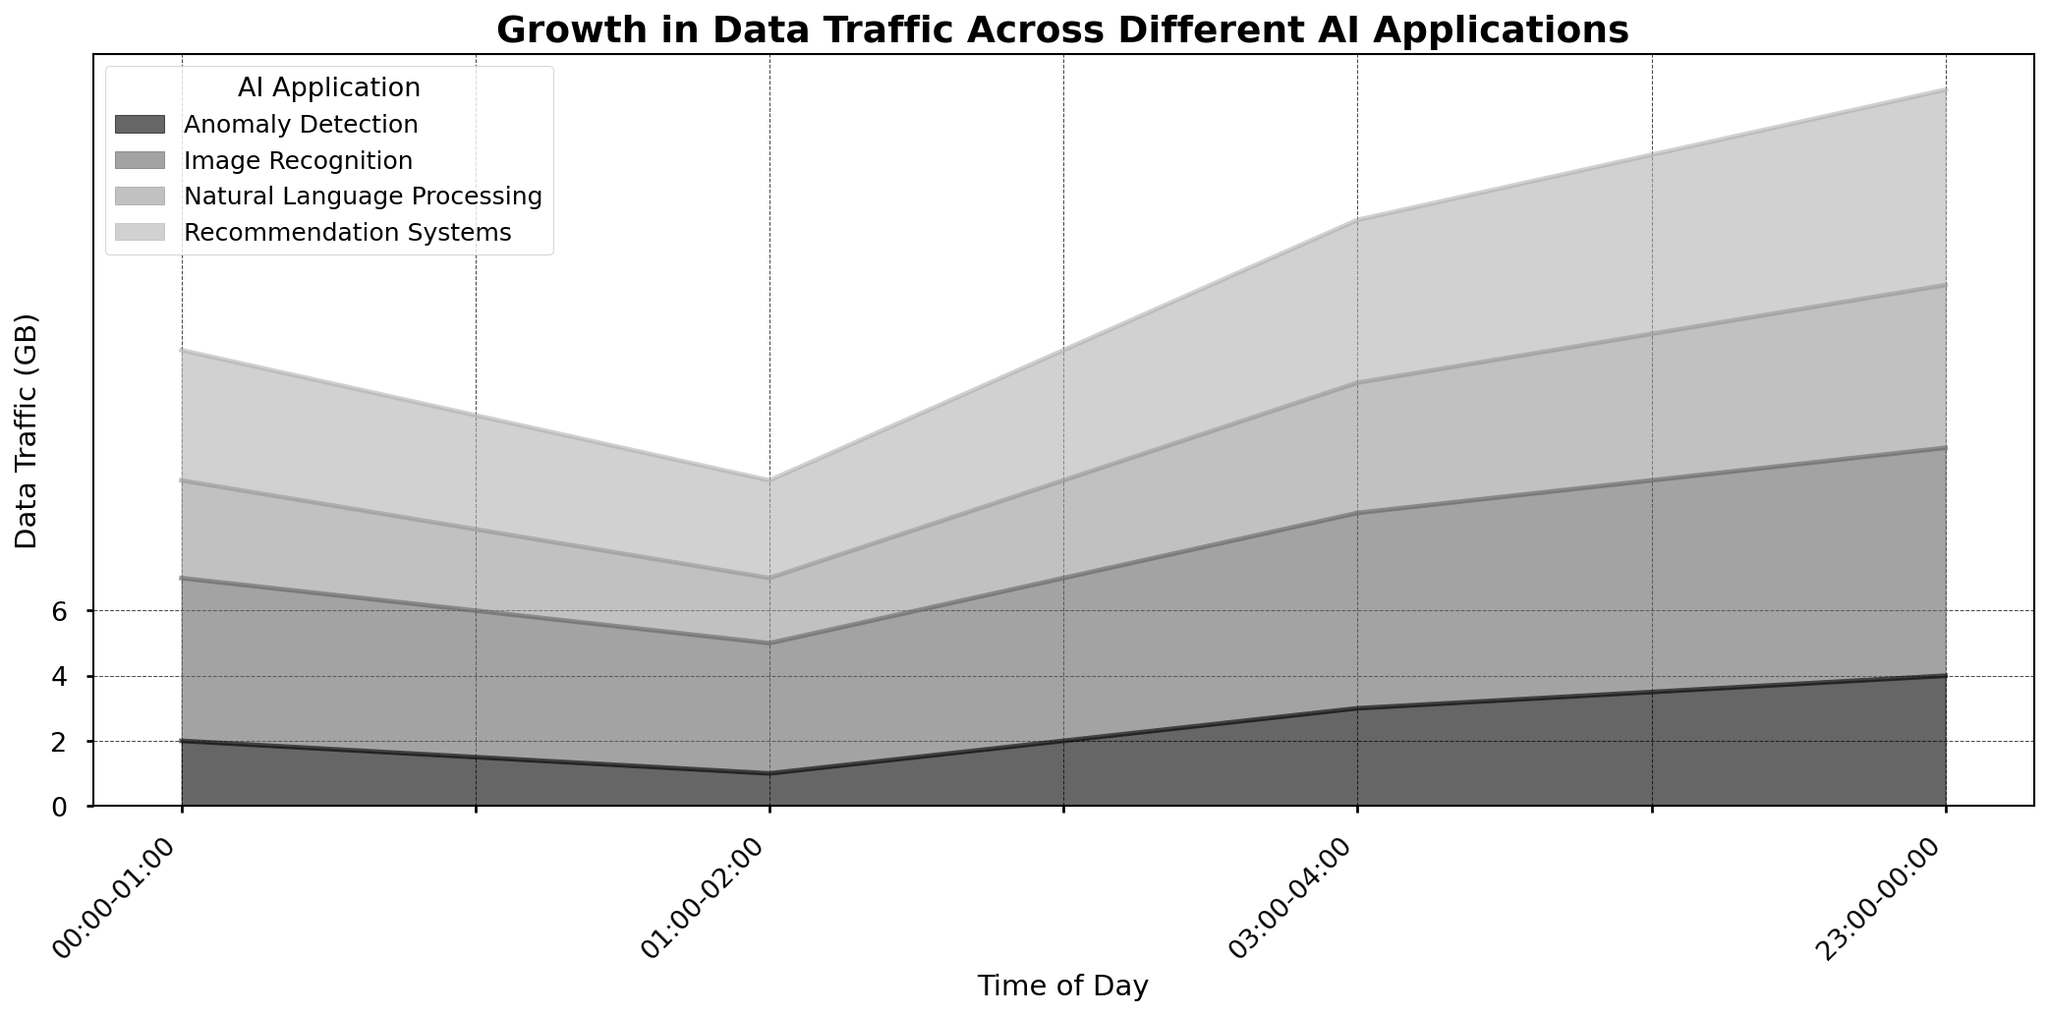What time of day has the highest total data traffic? To determine the time of day with the highest total data traffic, we need to sum the data traffic values for each time period across all AI applications. By looking at the area heights in the chart, "23:00-00:00" shows the highest combined values for all applications.
Answer: 23:00-00:00 Which AI application has the highest data traffic at "00:00-01:00"? At the "00:00-01:00" time slot, we compare the data traffic values of each AI application. The chart shows that Image Recognition has the highest data traffic of 5 GB.
Answer: Image Recognition Is data traffic for Recommendation Systems higher at "23:00-00:00" or "03:00-04:00"? To compare, we look at the area sizes for Recommendation Systems at both time slots. "23:00-00:00" has higher data traffic (6 GB) compared to "03:00-04:00" (5 GB).
Answer: 23:00-00:00 Rank the AI applications at "01:00-02:00" from highest to lowest data traffic. At "01:00-02:00", the data traffic for each application is: Image Recognition (4 GB), Recommendation Systems (3 GB), Natural Language Processing (2 GB), and Anomaly Detection (1 GB).
Answer: Image Recognition, Recommendation Systems, Natural Language Processing, Anomaly Detection Which AI application shows the least variation in data traffic across the day? By observing the consistency of the area sizes across all time slots, Natural Language Processing appears to have the most uniform distribution, showing less variation compared to others.
Answer: Natural Language Processing Calculate the total data traffic for Image Recognition across all time slots provided in the dataset. To find the total, we sum the data traffic for Image Recognition at each time slot: 5 GB (00:00-01:00) + 4 GB (01:00-02:00) + 6 GB (03:00-04:00) + 7 GB (23:00-00:00) = 22 GB.
Answer: 22 GB Which time slot displays the least data traffic for Anomaly Detection? By comparing the area heights for Anomaly Detection across all time slots, "01:00-02:00" displays the least data traffic with 1 GB.
Answer: 01:00-02:00 How much more data traffic does the "23:00-00:00" time slot have compared to "01:00-02:00" for Natural Language Processing? Data traffic for Natural Language Processing at "23:00-00:00" is 5 GB and at "01:00-02:00" is 2 GB. The difference is 5 - 2 = 3 GB.
Answer: 3 GB What is the average data traffic for Recommendation Systems over the given times? Sum of the data traffic for all time slots for Recommendation Systems: 4 GB (00:00-01:00) + 3 GB (01:00-02:00) + 5 GB (03:00-04:00) + 6 GB (23:00-00:00) = 18 GB. Average = 18 GB / 4 times = 4.5 GB.
Answer: 4.5 GB 